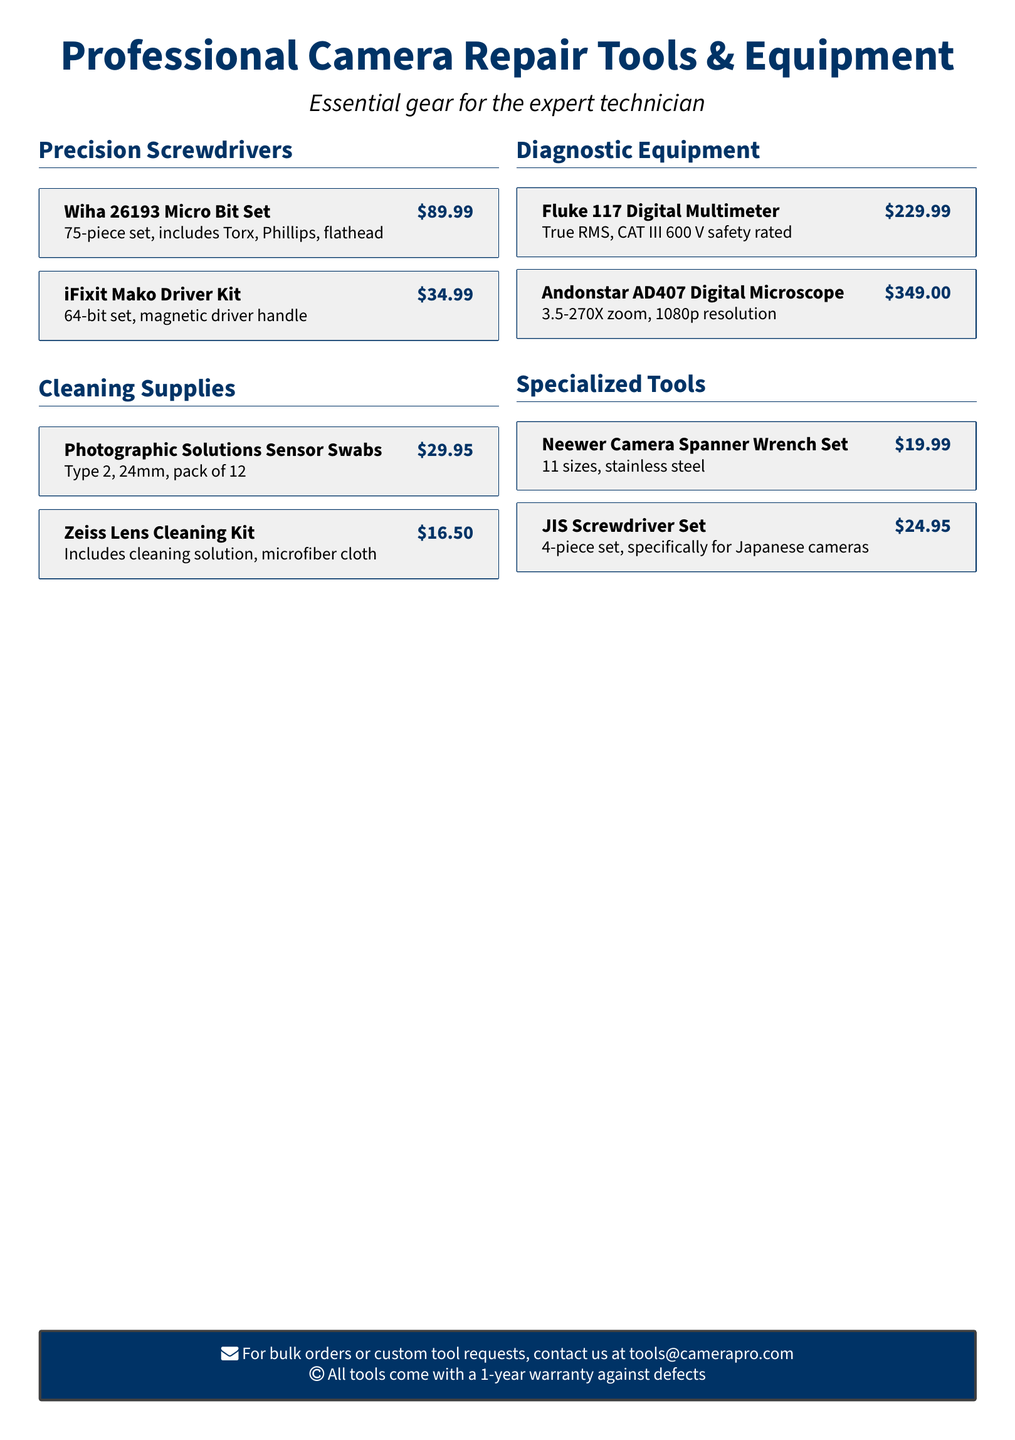what is the price of the Wiha 26193 Micro Bit Set? The price of the Wiha 26193 Micro Bit Set is mentioned in the pricing section of the document.
Answer: $89.99 how many pieces are in the iFixit Mako Driver Kit? The iFixit Mako Driver Kit is specified to include a certain number of pieces in the document.
Answer: 64-bit set what type of diagnostic equipment is mentioned? The document lists various diagnostic tools, asking for a specific type would reference the category mentioned.
Answer: Digital Microscope what is the size of the Photographic Solutions Sensor Swabs? The size of the sensor swabs is given as part of the product details in the catalog.
Answer: 24mm how many tools are in the Neewer Camera Spanner Wrench Set? The Neewer Camera Spanner Wrench Set includes a specified number of tools, which can be found in its description.
Answer: 11 sizes what warranty period do all tools come with? The warranty information outlines the period guaranteed against defects clearly in the document.
Answer: 1-year warranty which tool is specifically designed for Japanese cameras? The document states which tools cater specifically to certain camera types under the specialized tools section.
Answer: JIS Screwdriver Set what is the resolution of the Andonstar AD407 Digital Microscope? The resolution for the Andonstar AD407 is explicitly mentioned in the details of the product within the catalog.
Answer: 1080p resolution 